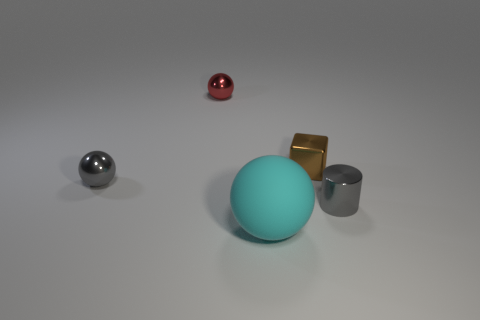Add 1 small purple things. How many objects exist? 6 Subtract all spheres. How many objects are left? 2 Add 2 metallic cubes. How many metallic cubes are left? 3 Add 1 large brown things. How many large brown things exist? 1 Subtract 0 yellow spheres. How many objects are left? 5 Subtract all gray spheres. Subtract all large cyan matte balls. How many objects are left? 3 